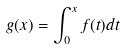Convert formula to latex. <formula><loc_0><loc_0><loc_500><loc_500>g ( x ) = \int _ { 0 } ^ { x } f ( t ) d t</formula> 